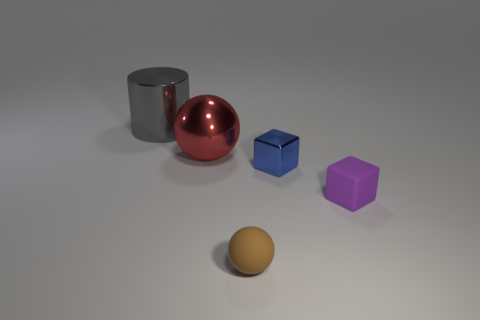Are there any other things that are the same shape as the blue metal object?
Your answer should be compact. Yes. What is the shape of the small matte thing to the right of the small brown rubber sphere?
Keep it short and to the point. Cube. The matte object that is behind the sphere that is in front of the ball that is behind the blue shiny thing is what shape?
Give a very brief answer. Cube. How many objects are either brown rubber things or small blocks?
Make the answer very short. 3. Is the shape of the tiny matte object that is right of the tiny brown rubber ball the same as the tiny rubber object to the left of the purple object?
Provide a short and direct response. No. What number of metal objects are left of the tiny metal object and in front of the gray cylinder?
Keep it short and to the point. 1. How many other things are the same size as the cylinder?
Give a very brief answer. 1. What is the thing that is behind the purple cube and on the right side of the red metal sphere made of?
Offer a very short reply. Metal. There is a large sphere; is its color the same as the sphere in front of the purple cube?
Keep it short and to the point. No. There is another thing that is the same shape as the tiny blue shiny thing; what is its size?
Give a very brief answer. Small. 